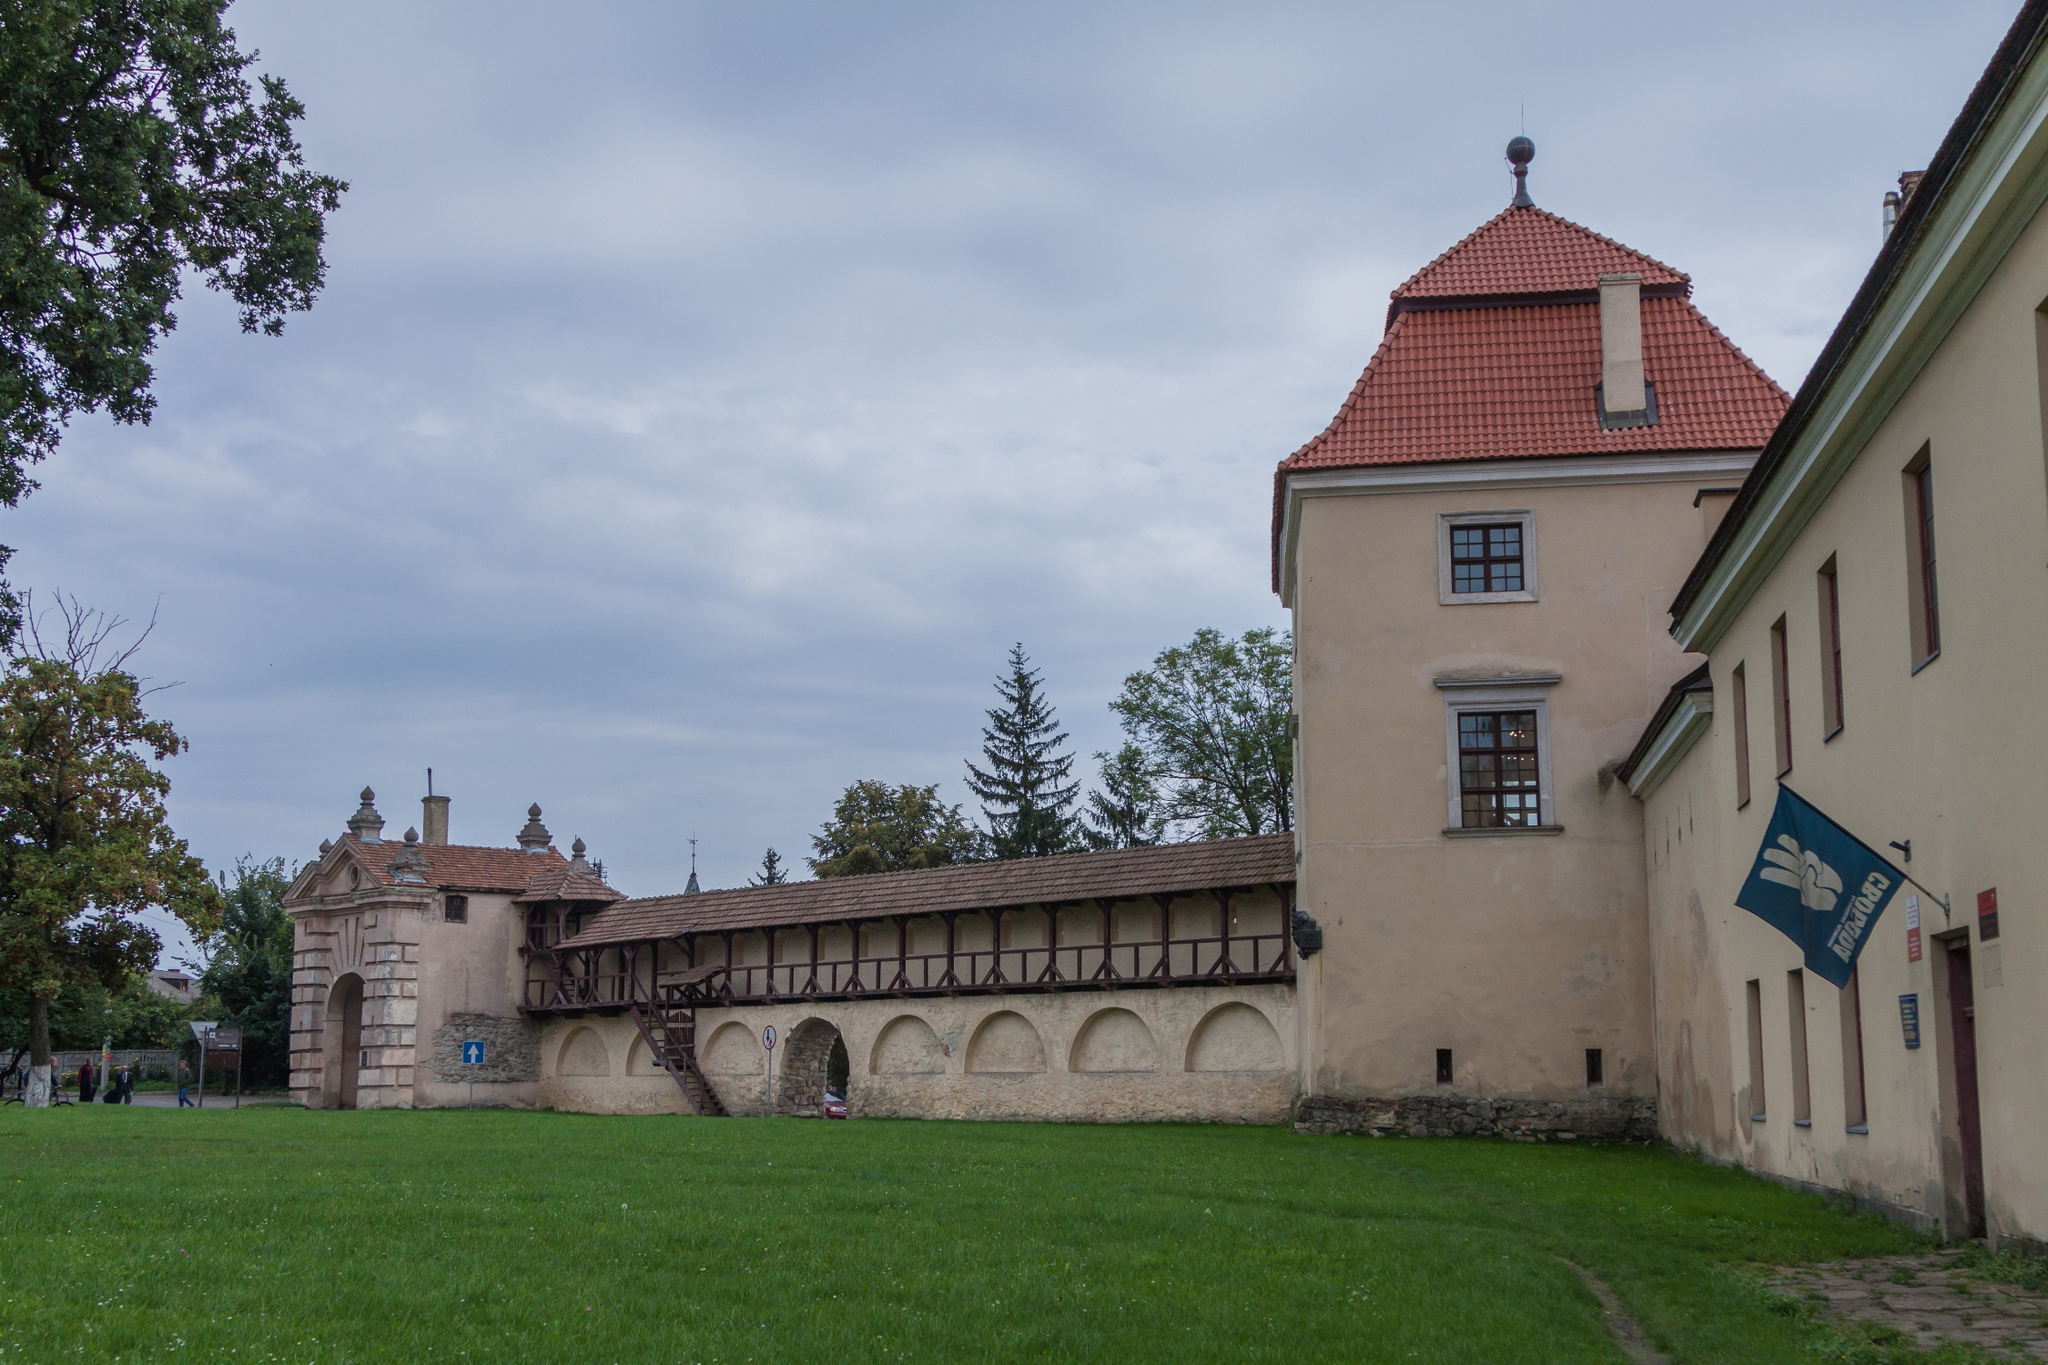Imagine this building in a different time period. What might it be used for if it were part of a fantasy world? In a fantastical world, this building could be an ancient wizard's abode where arcane knowledge is stored and powerful spells are cast. The red-tiled roof and sturdy structure might house expansive libraries filled with magical tomes and scrolls, while the elevated walkway serves as a vantage point for observing mystical creatures and celestial events. The lush surroundings could be enchanted gardens where rare alchemical ingredients grow and mystical rituals are conducted. The sign 'sa_11107' could represent an enchanted sigil or a mysterious code known only to a secret society of wizards. The building might also serve as a training ground for young apprentices learning the ways of magic, under the tutelage of wise and powerful sorcerers. 